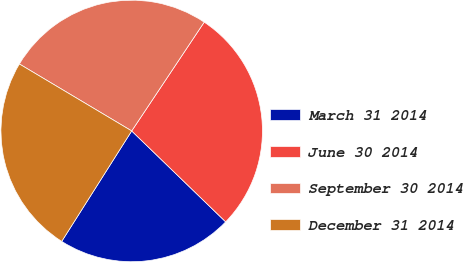Convert chart to OTSL. <chart><loc_0><loc_0><loc_500><loc_500><pie_chart><fcel>March 31 2014<fcel>June 30 2014<fcel>September 30 2014<fcel>December 31 2014<nl><fcel>21.75%<fcel>27.88%<fcel>25.8%<fcel>24.57%<nl></chart> 